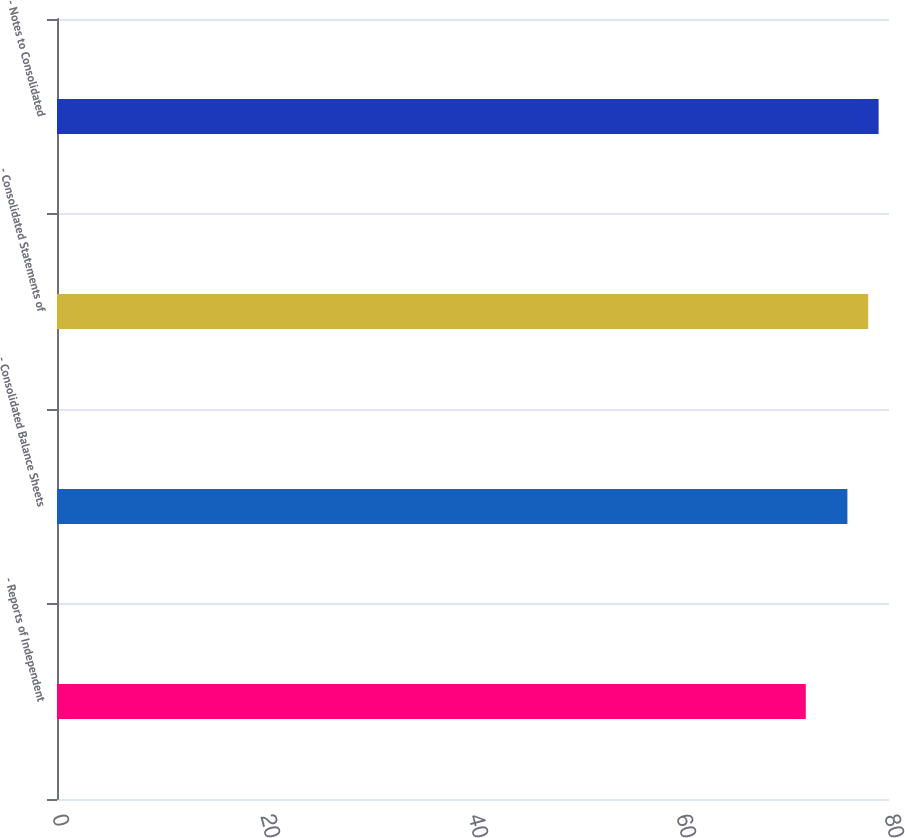Convert chart. <chart><loc_0><loc_0><loc_500><loc_500><bar_chart><fcel>- Reports of Independent<fcel>- Consolidated Balance Sheets<fcel>- Consolidated Statements of<fcel>- Notes to Consolidated<nl><fcel>72<fcel>76<fcel>78<fcel>79<nl></chart> 